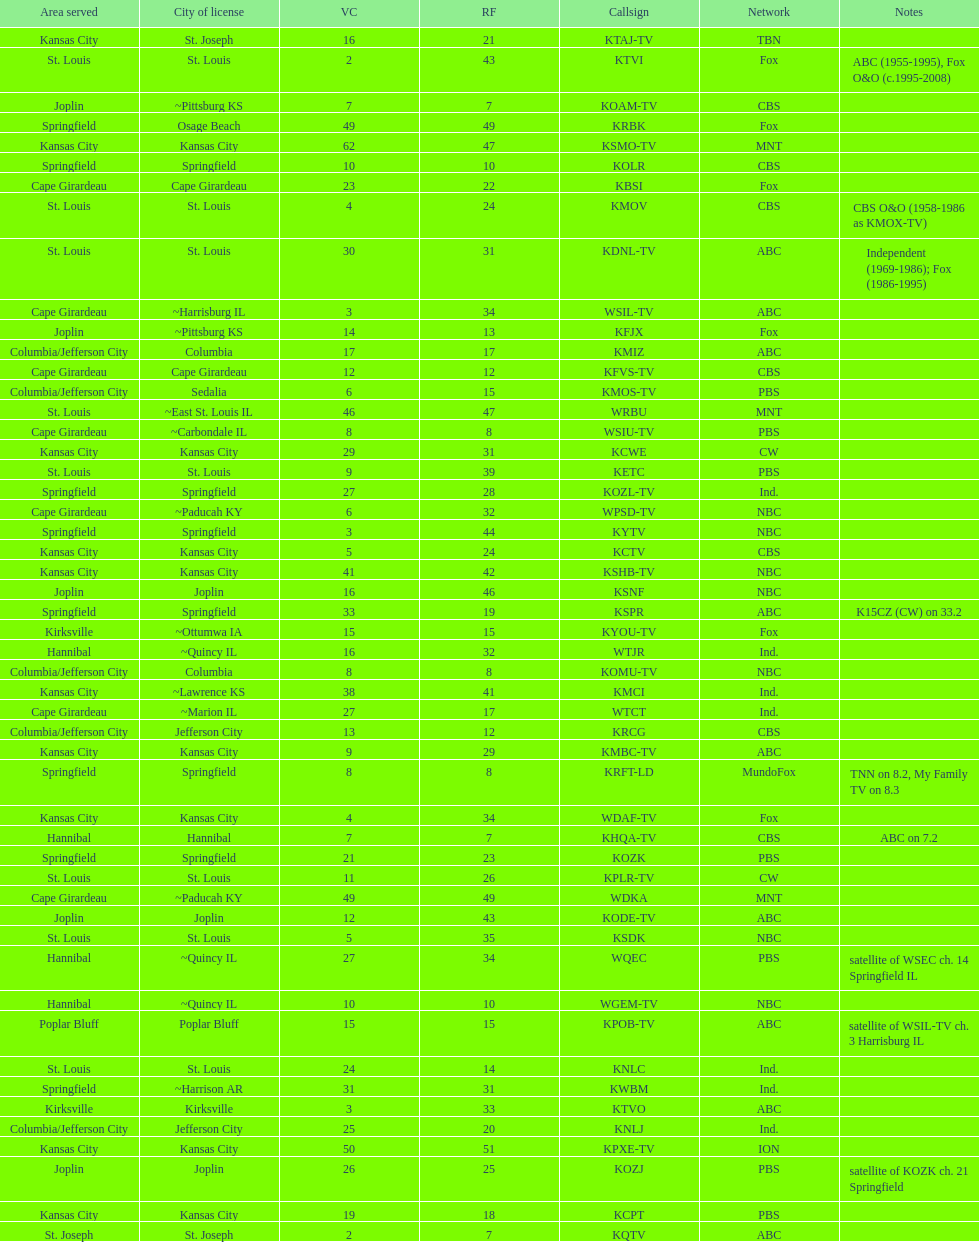How many of these missouri tv stations are actually licensed in a city in illinois (il)? 7. 